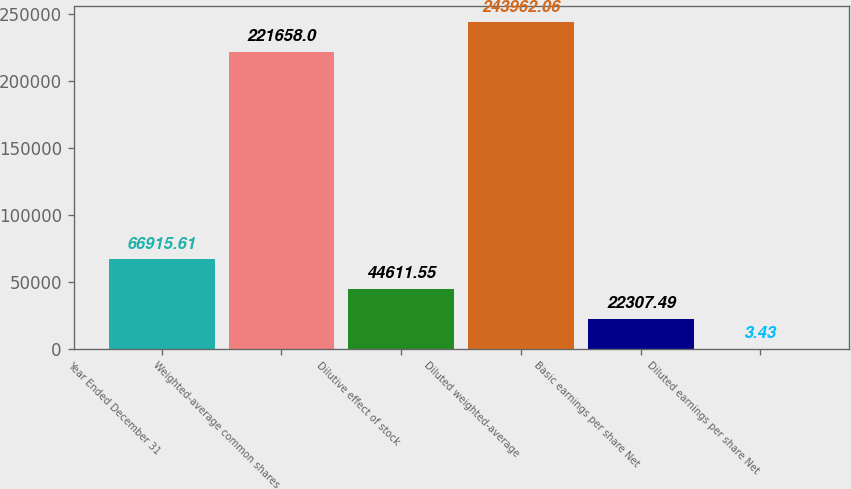Convert chart. <chart><loc_0><loc_0><loc_500><loc_500><bar_chart><fcel>Year Ended December 31<fcel>Weighted-average common shares<fcel>Dilutive effect of stock<fcel>Diluted weighted-average<fcel>Basic earnings per share Net<fcel>Diluted earnings per share Net<nl><fcel>66915.6<fcel>221658<fcel>44611.6<fcel>243962<fcel>22307.5<fcel>3.43<nl></chart> 